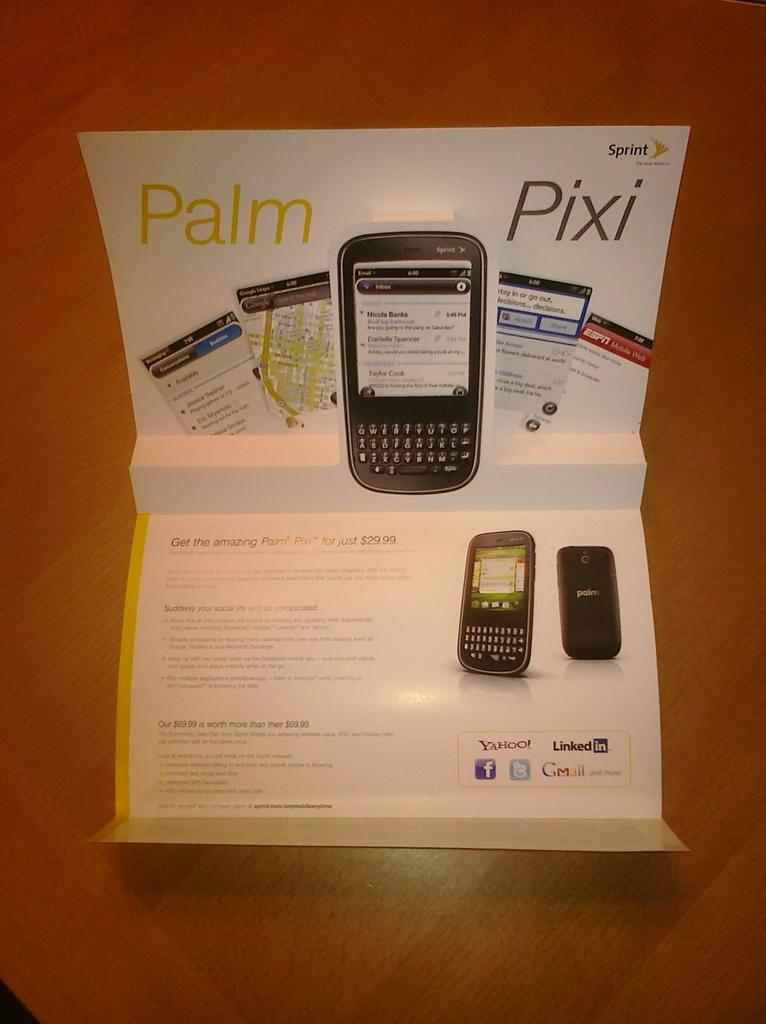<image>
Share a concise interpretation of the image provided. An ad for a phone called the Palm Pixi saying you can get it for $29.99. 